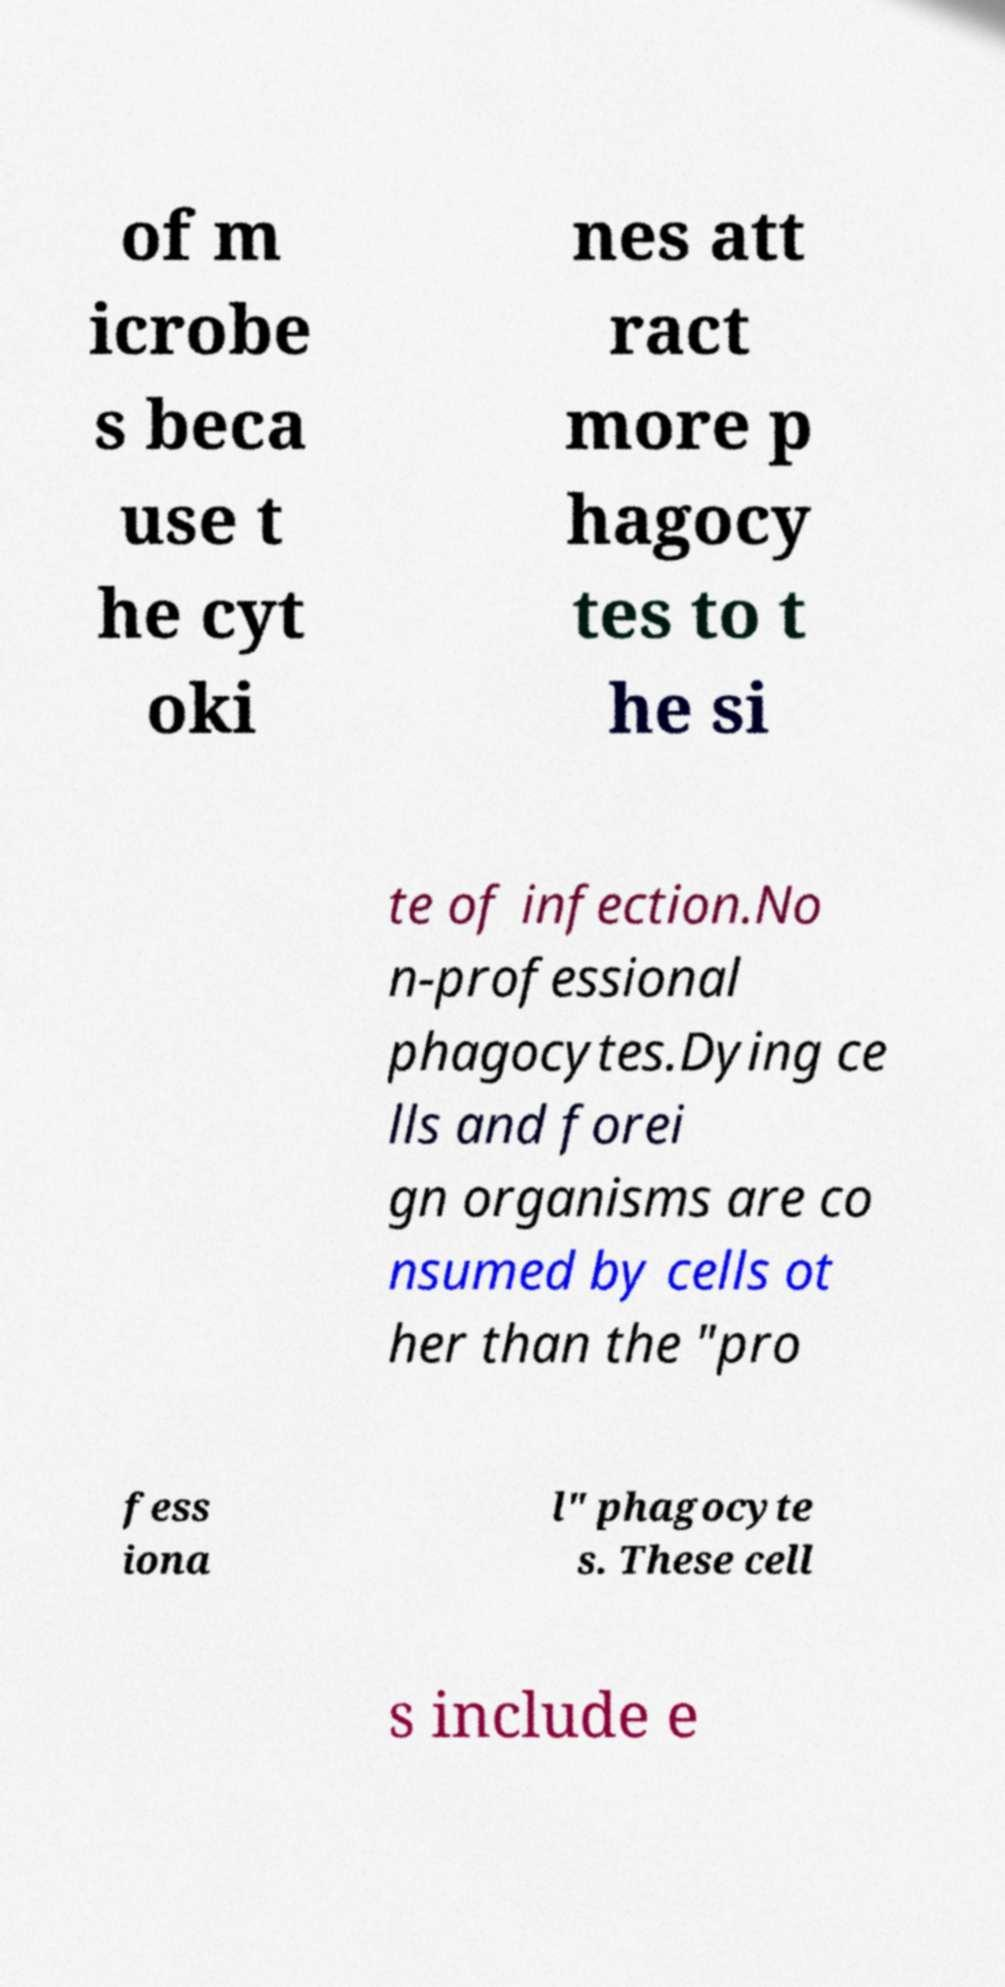Can you accurately transcribe the text from the provided image for me? of m icrobe s beca use t he cyt oki nes att ract more p hagocy tes to t he si te of infection.No n-professional phagocytes.Dying ce lls and forei gn organisms are co nsumed by cells ot her than the "pro fess iona l" phagocyte s. These cell s include e 